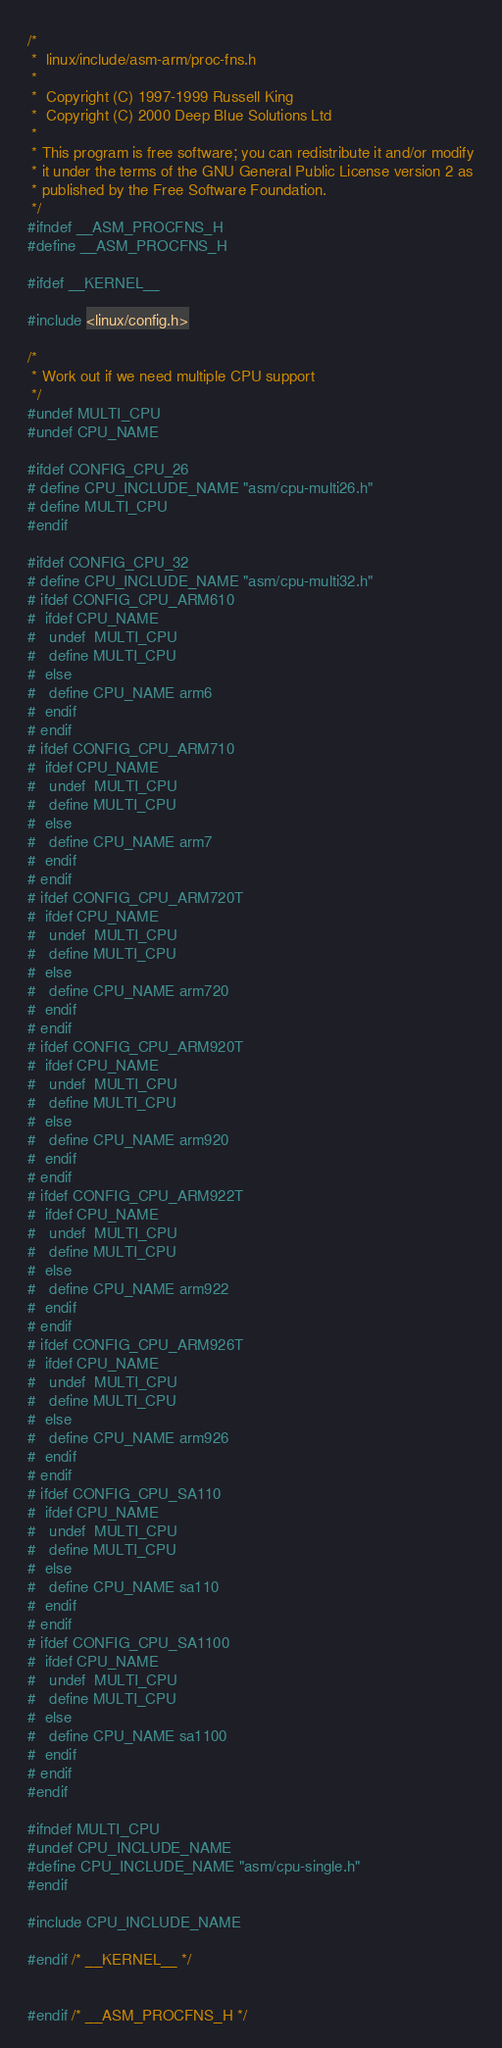<code> <loc_0><loc_0><loc_500><loc_500><_C_>/*
 *  linux/include/asm-arm/proc-fns.h
 *
 *  Copyright (C) 1997-1999 Russell King
 *  Copyright (C) 2000 Deep Blue Solutions Ltd
 *
 * This program is free software; you can redistribute it and/or modify
 * it under the terms of the GNU General Public License version 2 as
 * published by the Free Software Foundation.
 */
#ifndef __ASM_PROCFNS_H
#define __ASM_PROCFNS_H

#ifdef __KERNEL__

#include <linux/config.h>

/*
 * Work out if we need multiple CPU support
 */
#undef MULTI_CPU
#undef CPU_NAME

#ifdef CONFIG_CPU_26
# define CPU_INCLUDE_NAME "asm/cpu-multi26.h"
# define MULTI_CPU
#endif

#ifdef CONFIG_CPU_32
# define CPU_INCLUDE_NAME "asm/cpu-multi32.h"
# ifdef CONFIG_CPU_ARM610
#  ifdef CPU_NAME
#   undef  MULTI_CPU
#   define MULTI_CPU
#  else
#   define CPU_NAME arm6
#  endif
# endif
# ifdef CONFIG_CPU_ARM710
#  ifdef CPU_NAME
#   undef  MULTI_CPU
#   define MULTI_CPU
#  else
#   define CPU_NAME arm7
#  endif
# endif
# ifdef CONFIG_CPU_ARM720T
#  ifdef CPU_NAME
#   undef  MULTI_CPU
#   define MULTI_CPU
#  else
#   define CPU_NAME arm720
#  endif
# endif
# ifdef CONFIG_CPU_ARM920T
#  ifdef CPU_NAME
#   undef  MULTI_CPU
#   define MULTI_CPU
#  else
#   define CPU_NAME arm920
#  endif
# endif
# ifdef CONFIG_CPU_ARM922T
#  ifdef CPU_NAME
#   undef  MULTI_CPU
#   define MULTI_CPU
#  else
#   define CPU_NAME arm922
#  endif
# endif
# ifdef CONFIG_CPU_ARM926T
#  ifdef CPU_NAME
#   undef  MULTI_CPU
#   define MULTI_CPU
#  else
#   define CPU_NAME arm926
#  endif
# endif
# ifdef CONFIG_CPU_SA110
#  ifdef CPU_NAME
#   undef  MULTI_CPU
#   define MULTI_CPU
#  else
#   define CPU_NAME sa110
#  endif
# endif
# ifdef CONFIG_CPU_SA1100
#  ifdef CPU_NAME
#   undef  MULTI_CPU
#   define MULTI_CPU
#  else
#   define CPU_NAME sa1100
#  endif
# endif
#endif

#ifndef MULTI_CPU
#undef CPU_INCLUDE_NAME
#define CPU_INCLUDE_NAME "asm/cpu-single.h"
#endif

#include CPU_INCLUDE_NAME

#endif /* __KERNEL__ */


#endif /* __ASM_PROCFNS_H */
</code> 